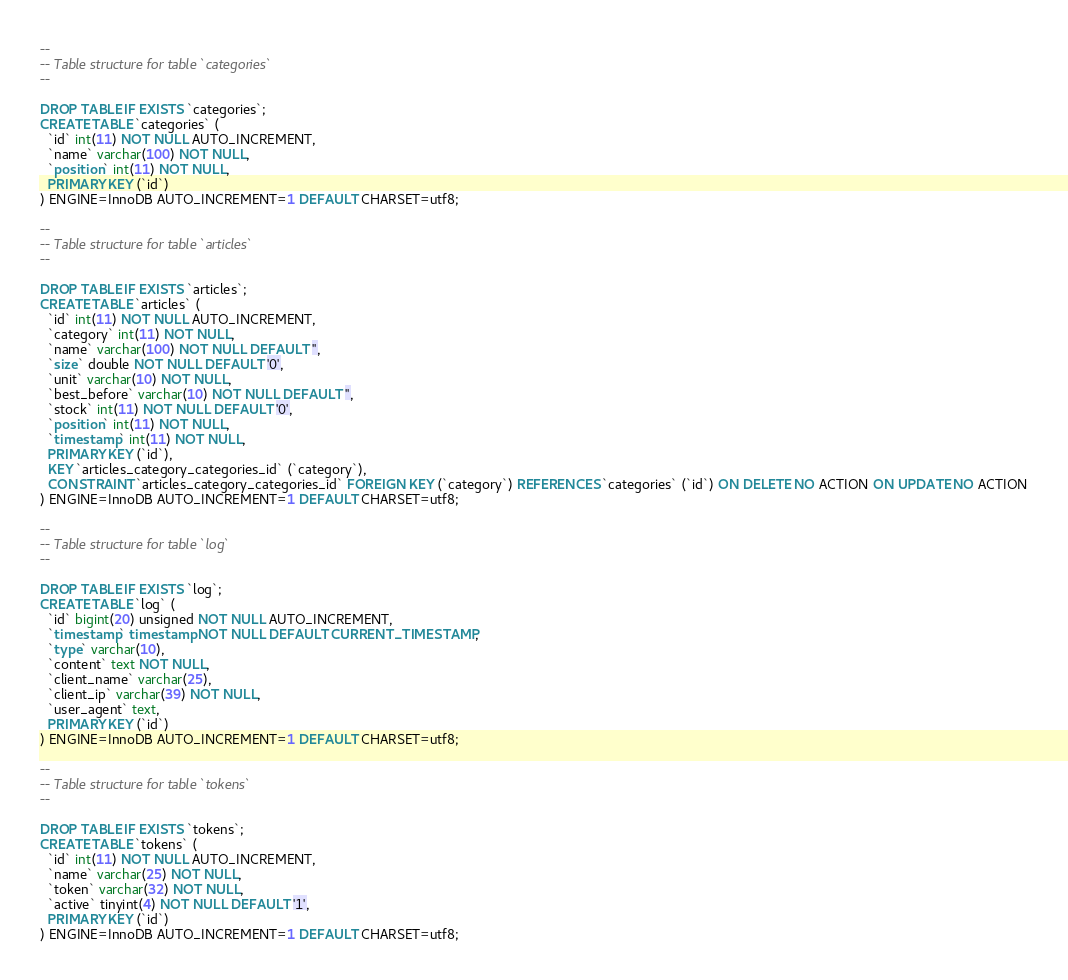Convert code to text. <code><loc_0><loc_0><loc_500><loc_500><_SQL_>
--
-- Table structure for table `categories`
--

DROP TABLE IF EXISTS `categories`;
CREATE TABLE `categories` (
  `id` int(11) NOT NULL AUTO_INCREMENT,
  `name` varchar(100) NOT NULL,
  `position` int(11) NOT NULL,
  PRIMARY KEY (`id`)
) ENGINE=InnoDB AUTO_INCREMENT=1 DEFAULT CHARSET=utf8;

--
-- Table structure for table `articles`
--

DROP TABLE IF EXISTS `articles`;
CREATE TABLE `articles` (
  `id` int(11) NOT NULL AUTO_INCREMENT,
  `category` int(11) NOT NULL,
  `name` varchar(100) NOT NULL DEFAULT '',
  `size` double NOT NULL DEFAULT '0',
  `unit` varchar(10) NOT NULL,
  `best_before` varchar(10) NOT NULL DEFAULT '',
  `stock` int(11) NOT NULL DEFAULT '0',
  `position` int(11) NOT NULL,
  `timestamp` int(11) NOT NULL,
  PRIMARY KEY (`id`),
  KEY `articles_category_categories_id` (`category`),
  CONSTRAINT `articles_category_categories_id` FOREIGN KEY (`category`) REFERENCES `categories` (`id`) ON DELETE NO ACTION ON UPDATE NO ACTION
) ENGINE=InnoDB AUTO_INCREMENT=1 DEFAULT CHARSET=utf8;

--
-- Table structure for table `log`
--

DROP TABLE IF EXISTS `log`;
CREATE TABLE `log` (
  `id` bigint(20) unsigned NOT NULL AUTO_INCREMENT,
  `timestamp` timestamp NOT NULL DEFAULT CURRENT_TIMESTAMP,
  `type` varchar(10),
  `content` text NOT NULL,
  `client_name` varchar(25),
  `client_ip` varchar(39) NOT NULL,
  `user_agent` text,
  PRIMARY KEY (`id`)
) ENGINE=InnoDB AUTO_INCREMENT=1 DEFAULT CHARSET=utf8;

--
-- Table structure for table `tokens`
--

DROP TABLE IF EXISTS `tokens`;
CREATE TABLE `tokens` (
  `id` int(11) NOT NULL AUTO_INCREMENT,
  `name` varchar(25) NOT NULL,
  `token` varchar(32) NOT NULL,
  `active` tinyint(4) NOT NULL DEFAULT '1',
  PRIMARY KEY (`id`)
) ENGINE=InnoDB AUTO_INCREMENT=1 DEFAULT CHARSET=utf8;
</code> 